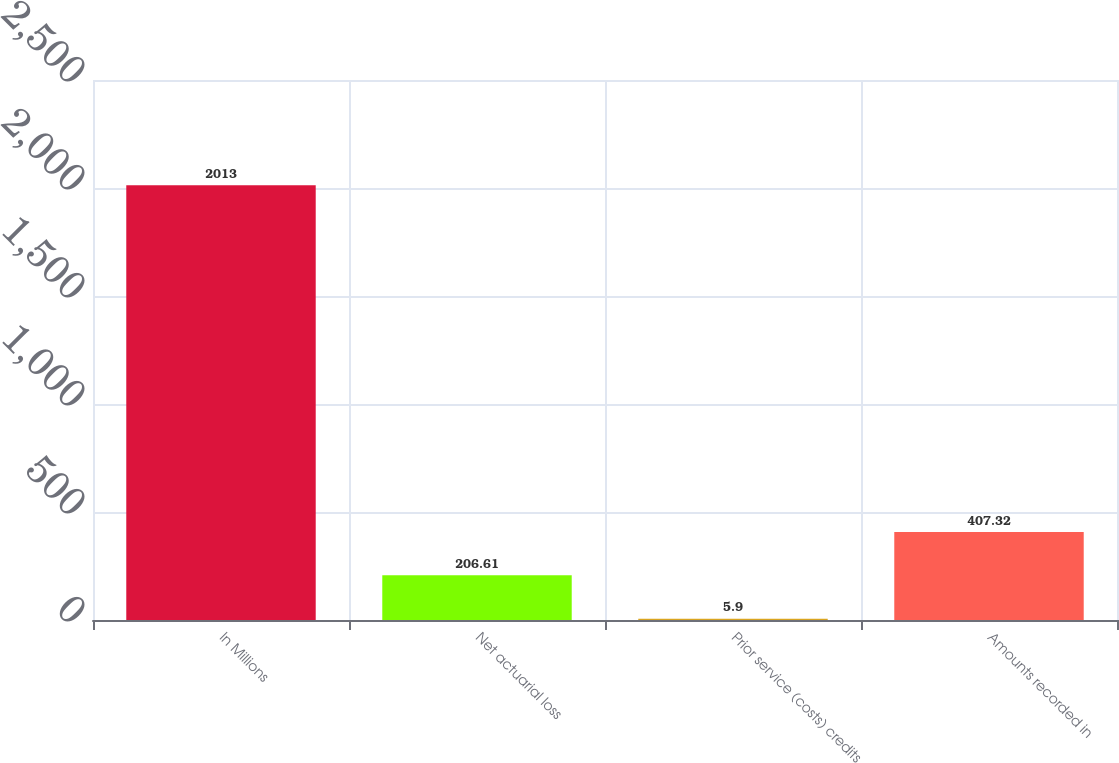Convert chart to OTSL. <chart><loc_0><loc_0><loc_500><loc_500><bar_chart><fcel>In Millions<fcel>Net actuarial loss<fcel>Prior service (costs) credits<fcel>Amounts recorded in<nl><fcel>2013<fcel>206.61<fcel>5.9<fcel>407.32<nl></chart> 